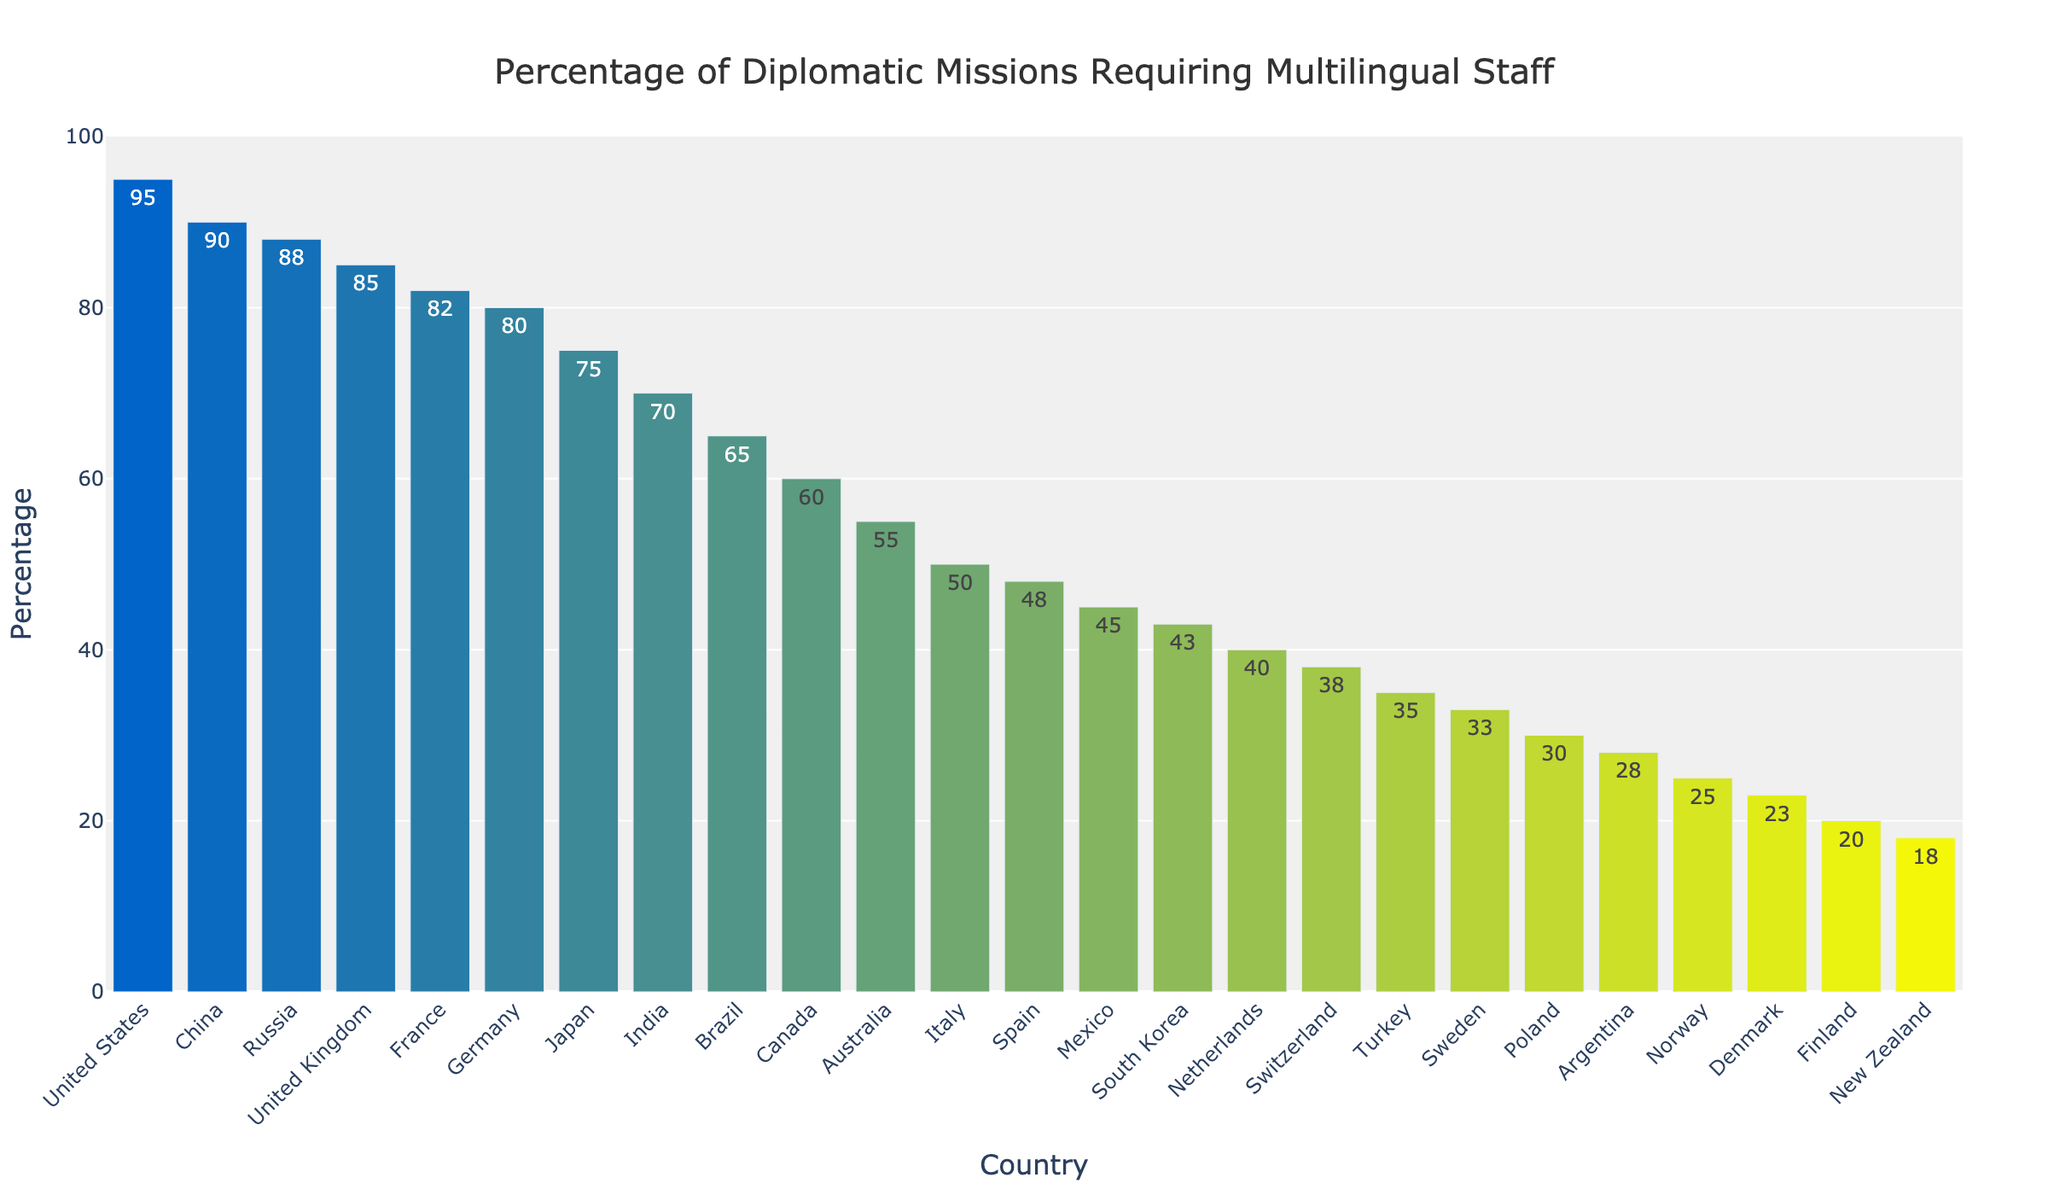what's the percentage difference in multilingual staff requirement between the United States and New Zealand? The United States has a percentage of 95 while New Zealand has 18. The difference is calculated as 95 - 18 = 77
Answer: 77 which country has the lowest percentage of multilingual staff requirement? By looking at the bar chart and comparing the lengths, the bar for New Zealand is the shortest
Answer: New Zealand how do the percentages of France and Germany compare? France has a percentage of 82, and Germany has 80. Since 82 is more than 80, France requires a higher percentage of multilingual staff
Answer: France requires more what is the combined percentage for Japan, India, and Brazil? Add the individual percentages: Japan (75) + India (70) + Brazil (65) = 210
Answer: 210 which countries have a multilingual staff requirement above 80%? Identifying the countries with percentages of 80% or more: United States, China, Russia, United Kingdom, France, and Germany
Answer: United States, China, Russia, United Kingdom, France, Germany what is the median percentage of multilingual staff requirement among the listed countries? When the percentages are listed in ascending order, the median is the middle value. With 26 countries, the median is the average of the 13th (Spain, 48%) and 14th (Mexico, 45%) values: (48+45)/2 = 46.5
Answer: 46.5 is the percentage requirement for multilingual staff in Canada higher or lower than in Australia? Canada has a percentage of 60, while Australia has 55. Since 60 is greater than 55, Canada has a higher percentage requirement
Answer: higher which color is used for Germany's bar? By examining the color gradient on the chart, Germany's bar is in a medium shade between green and blue
Answer: medium shade how many countries have a multilingual staff requirement below 50%? By counting the bars with percentages below 50%: Italy, Spain, Mexico, South Korea, Netherlands, Switzerland, Turkey, Sweden, Poland, Argentina, Norway, Denmark, Finland, New Zealand make 14 countries
Answer: 14 what is the percentage difference between Spain and Sweden? Spain has a percentage of 48, and Sweden has 33. The difference is calculated as 48 - 33 = 15
Answer: 15 